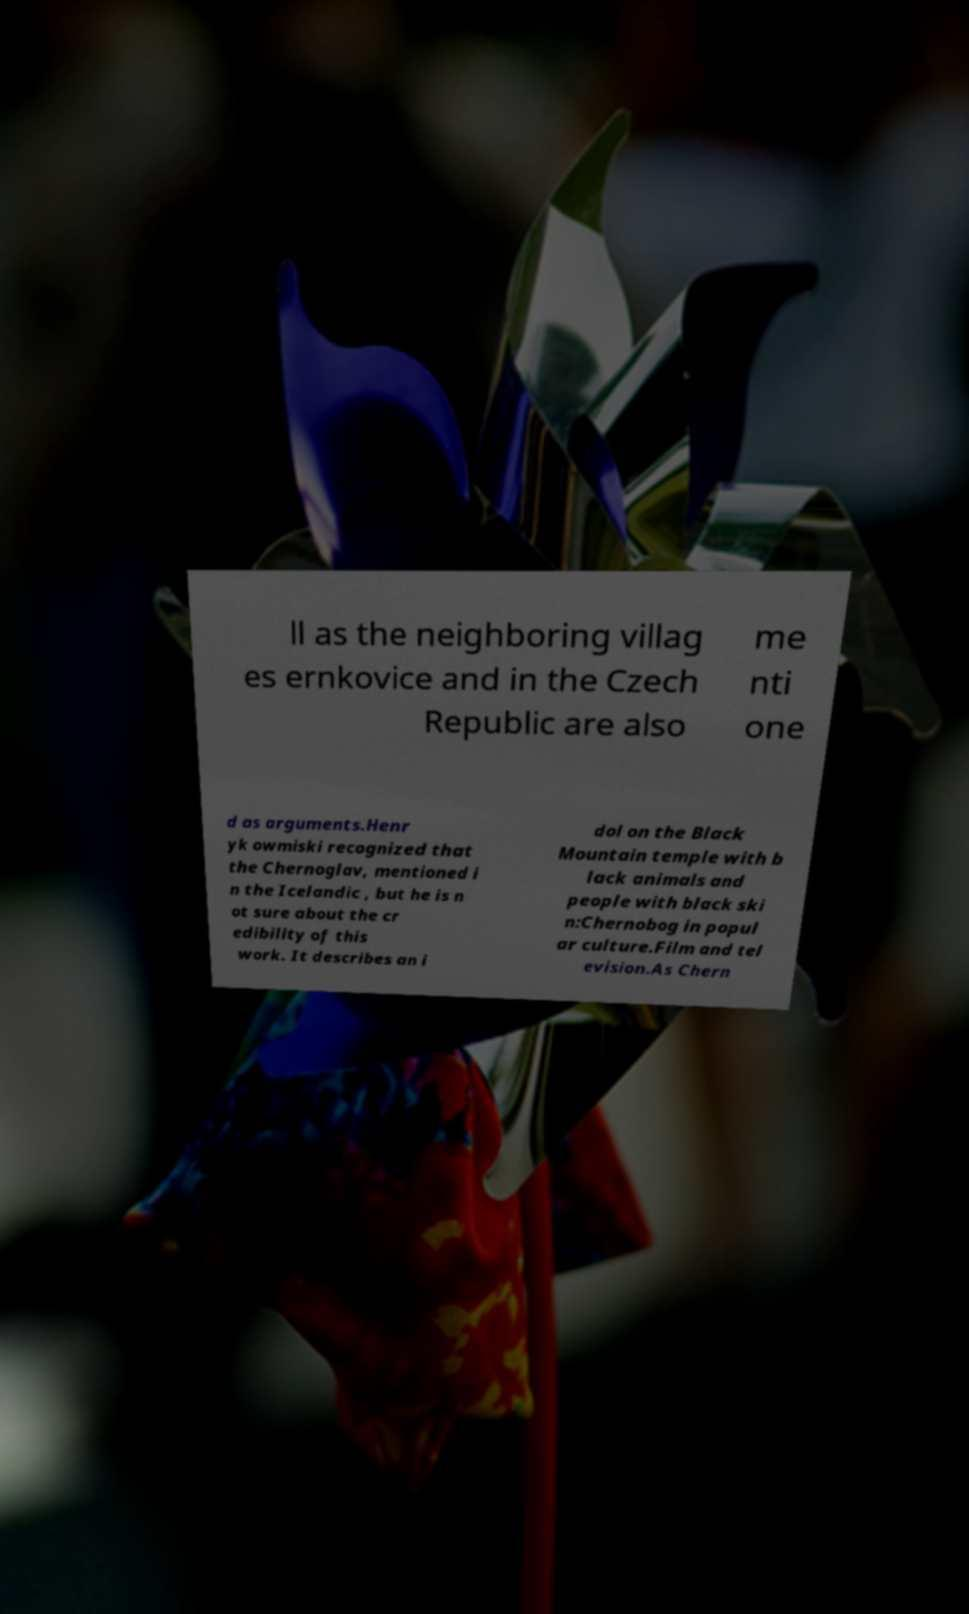For documentation purposes, I need the text within this image transcribed. Could you provide that? ll as the neighboring villag es ernkovice and in the Czech Republic are also me nti one d as arguments.Henr yk owmiski recognized that the Chernoglav, mentioned i n the Icelandic , but he is n ot sure about the cr edibility of this work. It describes an i dol on the Black Mountain temple with b lack animals and people with black ski n:Chernobog in popul ar culture.Film and tel evision.As Chern 